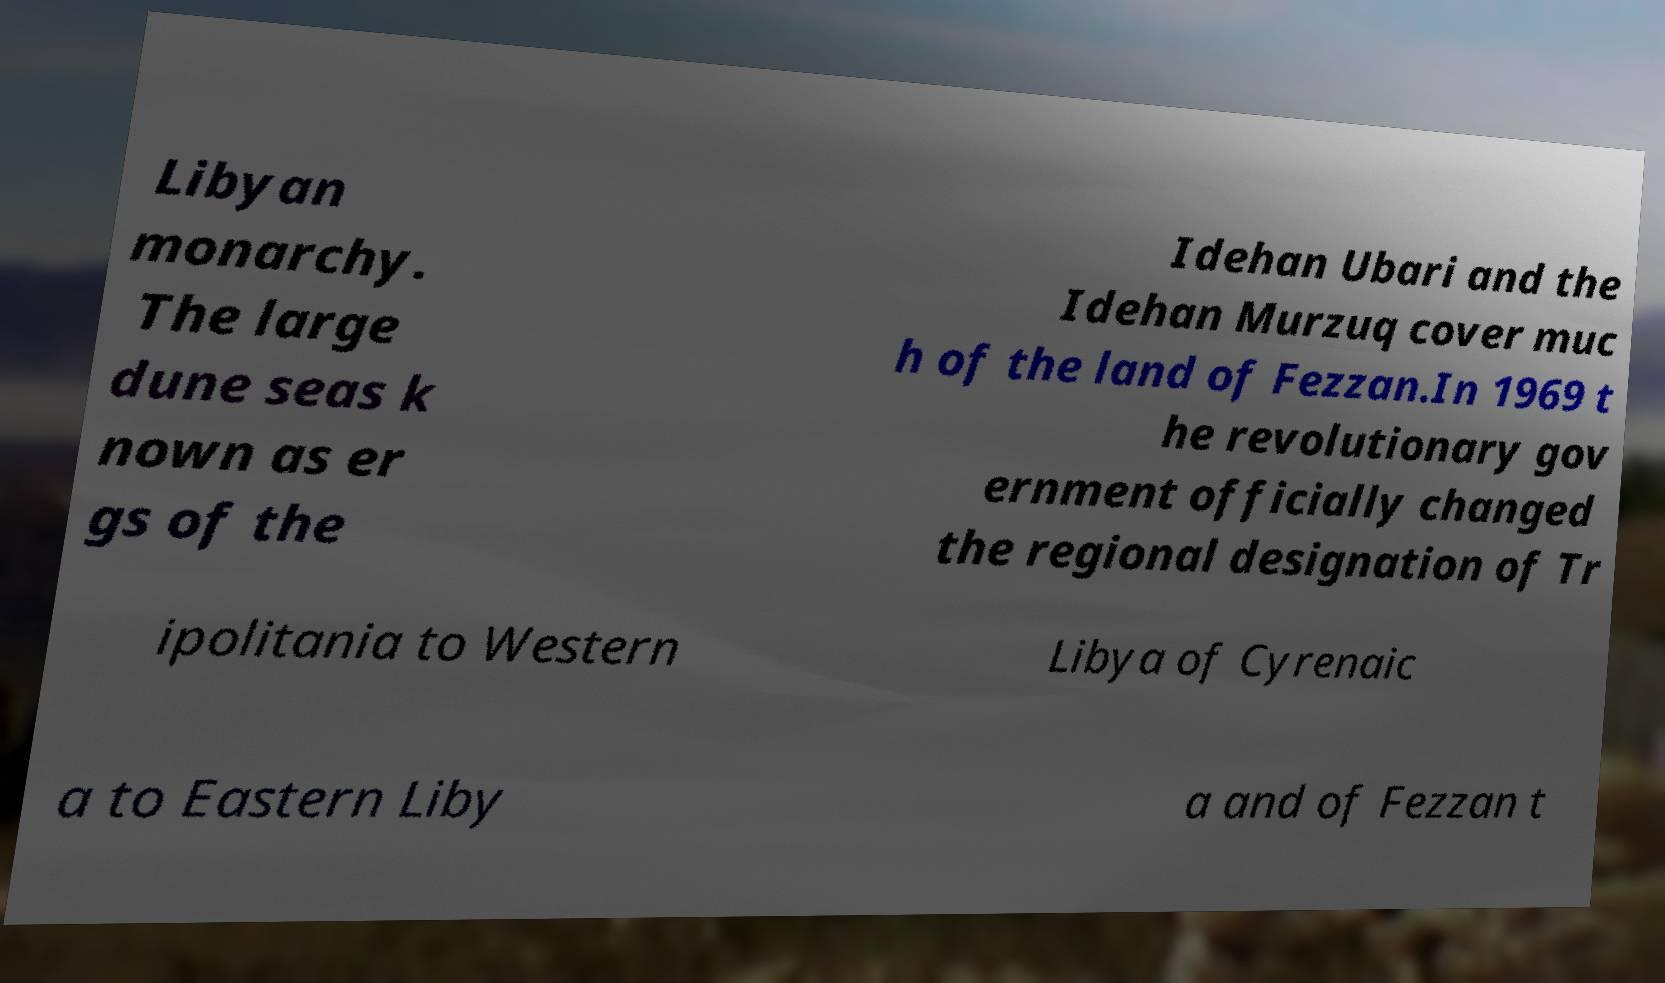Could you extract and type out the text from this image? Libyan monarchy. The large dune seas k nown as er gs of the Idehan Ubari and the Idehan Murzuq cover muc h of the land of Fezzan.In 1969 t he revolutionary gov ernment officially changed the regional designation of Tr ipolitania to Western Libya of Cyrenaic a to Eastern Liby a and of Fezzan t 